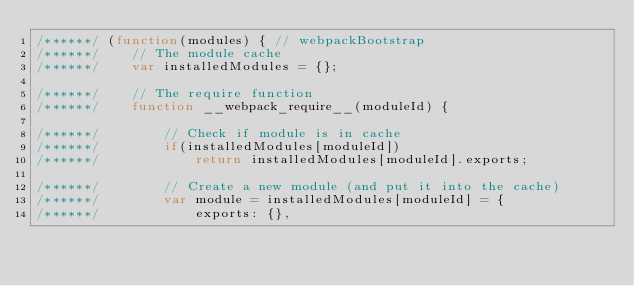<code> <loc_0><loc_0><loc_500><loc_500><_JavaScript_>/******/ (function(modules) { // webpackBootstrap
/******/ 	// The module cache
/******/ 	var installedModules = {};

/******/ 	// The require function
/******/ 	function __webpack_require__(moduleId) {

/******/ 		// Check if module is in cache
/******/ 		if(installedModules[moduleId])
/******/ 			return installedModules[moduleId].exports;

/******/ 		// Create a new module (and put it into the cache)
/******/ 		var module = installedModules[moduleId] = {
/******/ 			exports: {},</code> 